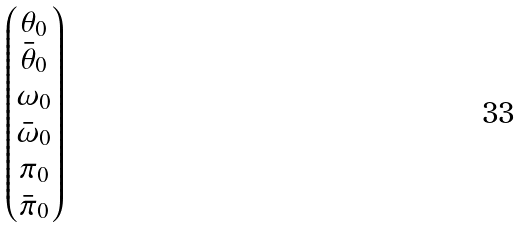Convert formula to latex. <formula><loc_0><loc_0><loc_500><loc_500>\begin{pmatrix} \theta _ { 0 } \\ \bar { \theta } _ { 0 } \\ \omega _ { 0 } \\ \bar { \omega } _ { 0 } \\ \pi _ { 0 } \\ \bar { \pi } _ { 0 } \end{pmatrix}</formula> 